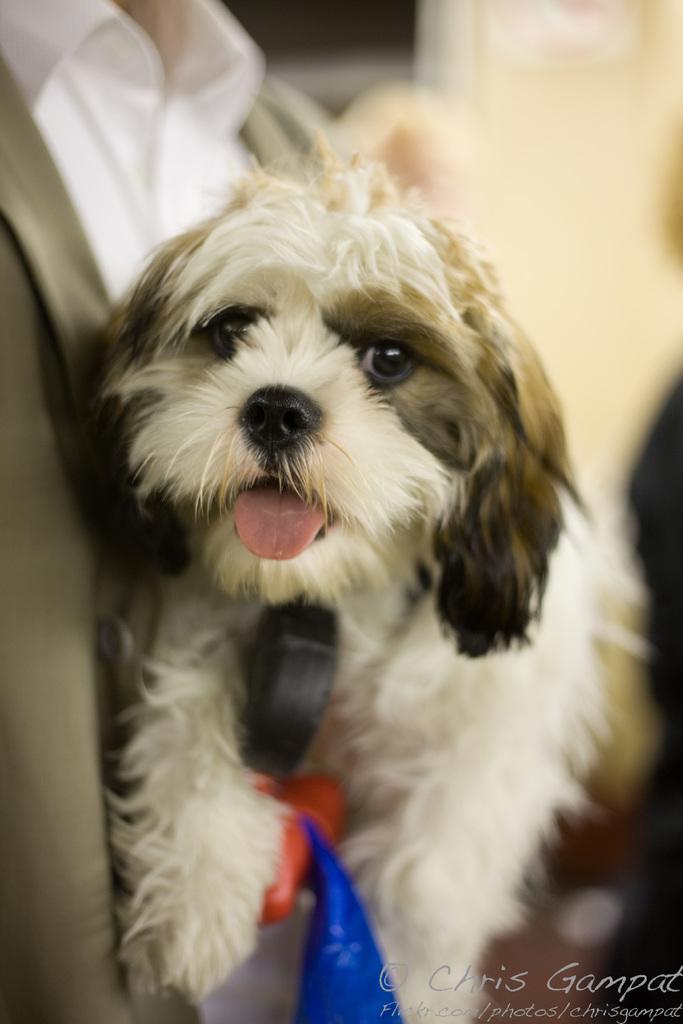Could you give a brief overview of what you see in this image? In this image I can see a person holding a puppy. In the bottom right there is some text. The background is blurred. 